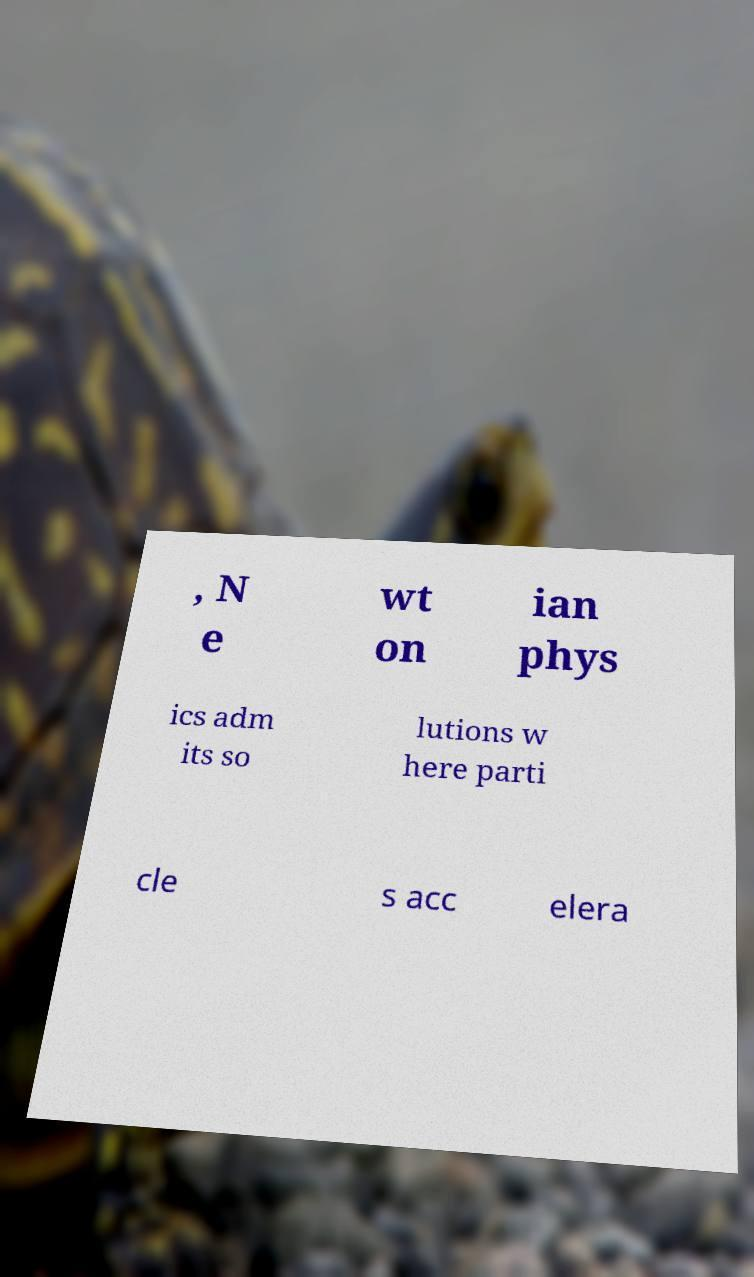Please identify and transcribe the text found in this image. , N e wt on ian phys ics adm its so lutions w here parti cle s acc elera 